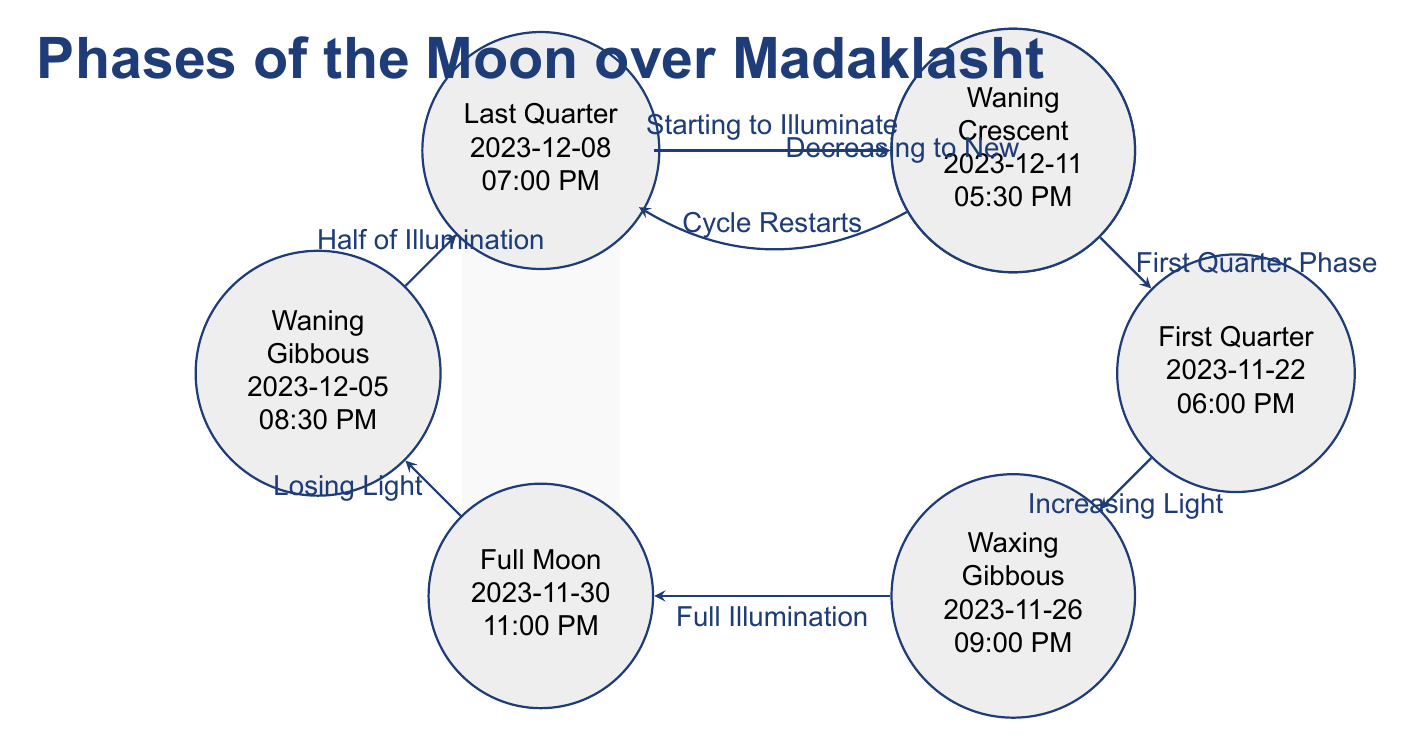What is the date of the New Moon in Madaklasht? The diagram shows the New Moon phase at the top left node, which indicates the date is 2023-11-12.
Answer: 2023-11-12 How many phases of the Moon are depicted in the diagram? The diagram contains eight distinct phases of the Moon, each represented as a separate node, visible when counting them from New Moon to Waning Crescent.
Answer: 8 Which phase occurs just before the Full Moon? According to the arrow flow in the diagram, the phase immediately before Full Moon is Waxing Gibbous.
Answer: Waxing Gibbous What is the time of the Full Moon? The Full Moon phase, located in the diagram, indicates that it occurs at 11:00 PM on the date of 2023-11-30.
Answer: 11:00 PM What is the sequence of illumination from the New Moon to the Full Moon? Starting from New Moon at 10:00 PM, the phases progress through Waxing Crescent, First Quarter, and Waxing Gibbous until reaching Full Moon at 11:00 PM.
Answer: New Moon, Waxing Crescent, First Quarter, Waxing Gibbous What date marks the Last Quarter phase? The diagram lists the Last Quarter phase occurring on 2023-12-08.
Answer: 2023-12-08 Which phase is at the bottom left of the diagram? The node located at the bottom left of the diagram is the Waxing Gibbous phase.
Answer: Waxing Gibbous What describes the transition from Waxing Gibbous to Full Moon? The transition from Waxing Gibbous to Full Moon is described in the arrow as "Full Illumination".
Answer: Full Illumination What time does the Waning Crescent occur? The diagram specifies that the Waning Crescent phase takes place at 5:30 PM on 2023-12-11.
Answer: 5:30 PM 